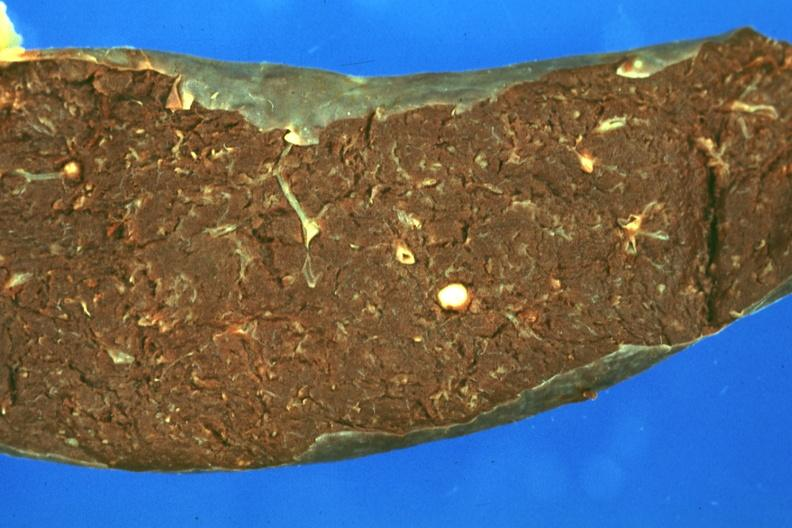does this image show fixed tissue but color not too bad single typical lesion?
Answer the question using a single word or phrase. Yes 